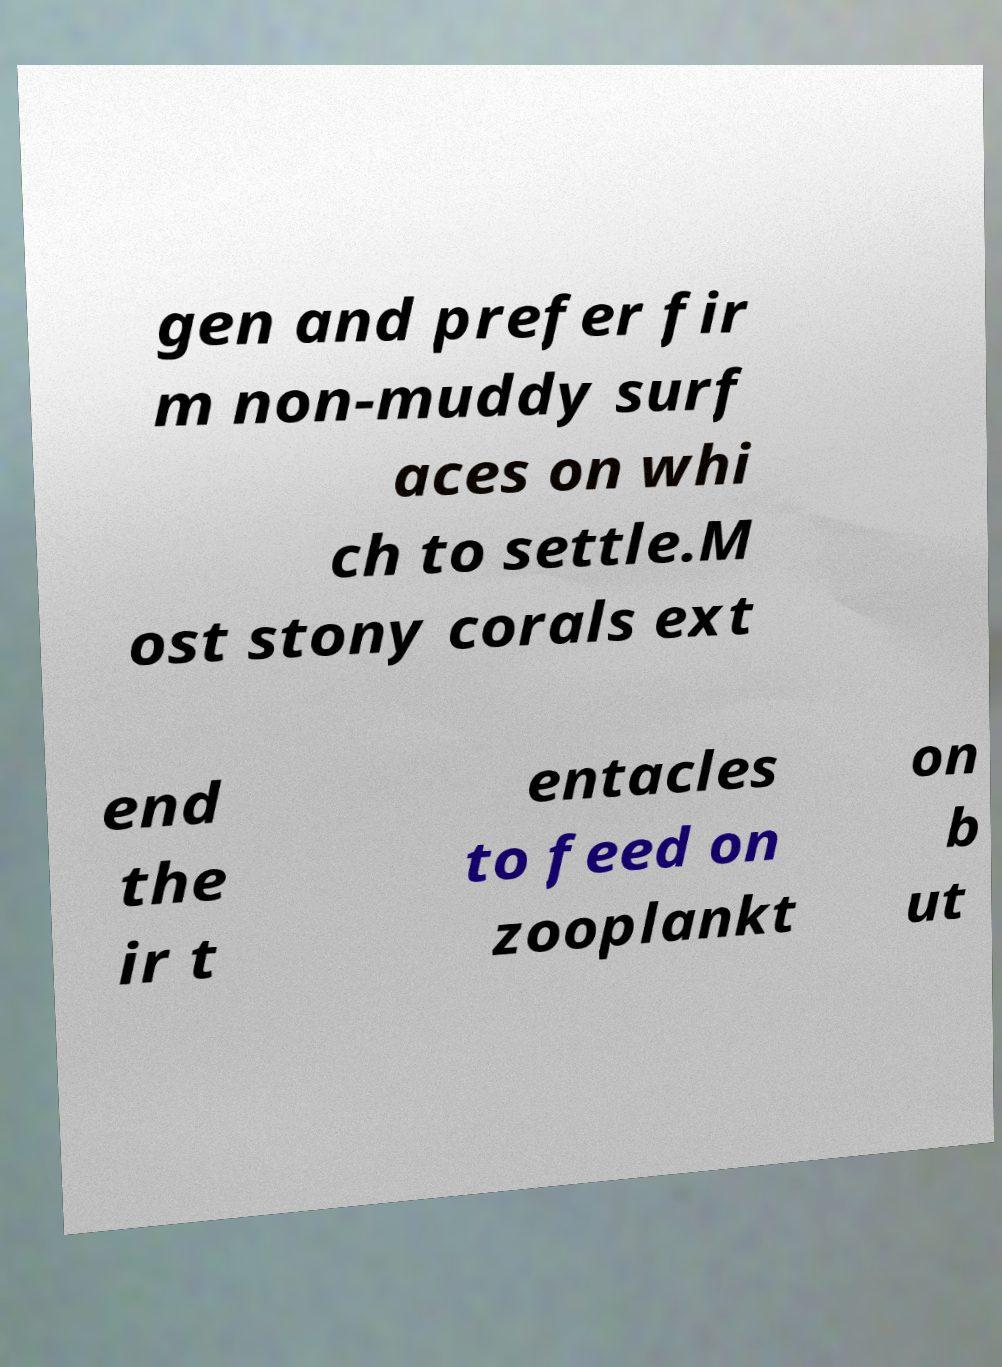Please read and relay the text visible in this image. What does it say? gen and prefer fir m non-muddy surf aces on whi ch to settle.M ost stony corals ext end the ir t entacles to feed on zooplankt on b ut 